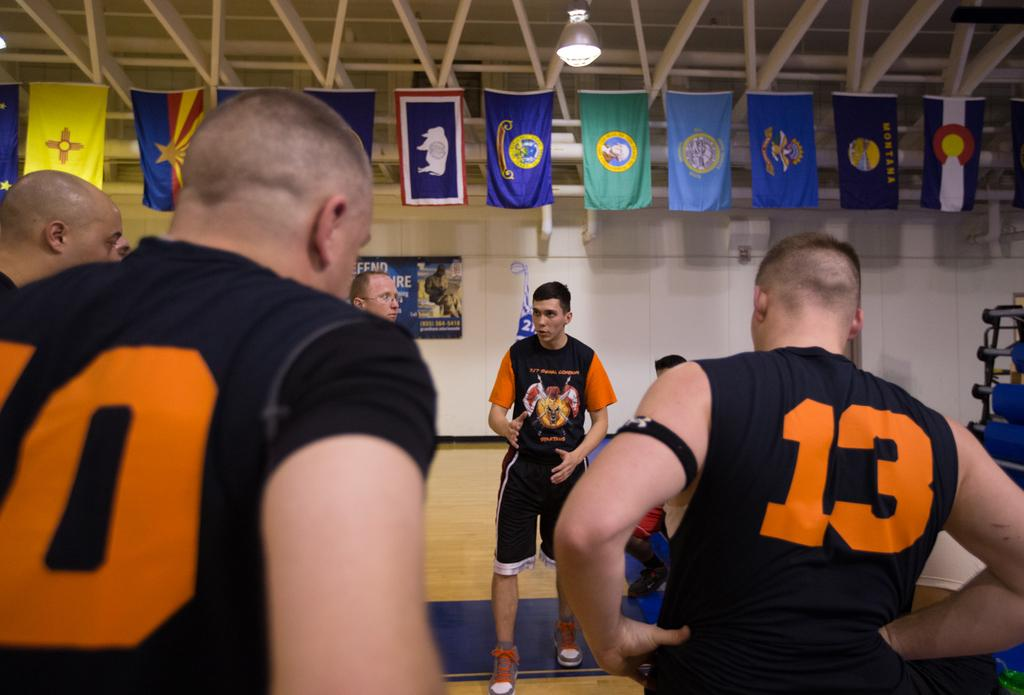<image>
Summarize the visual content of the image. Two men wearing numbers 10 and 13 listening to another man speak. 